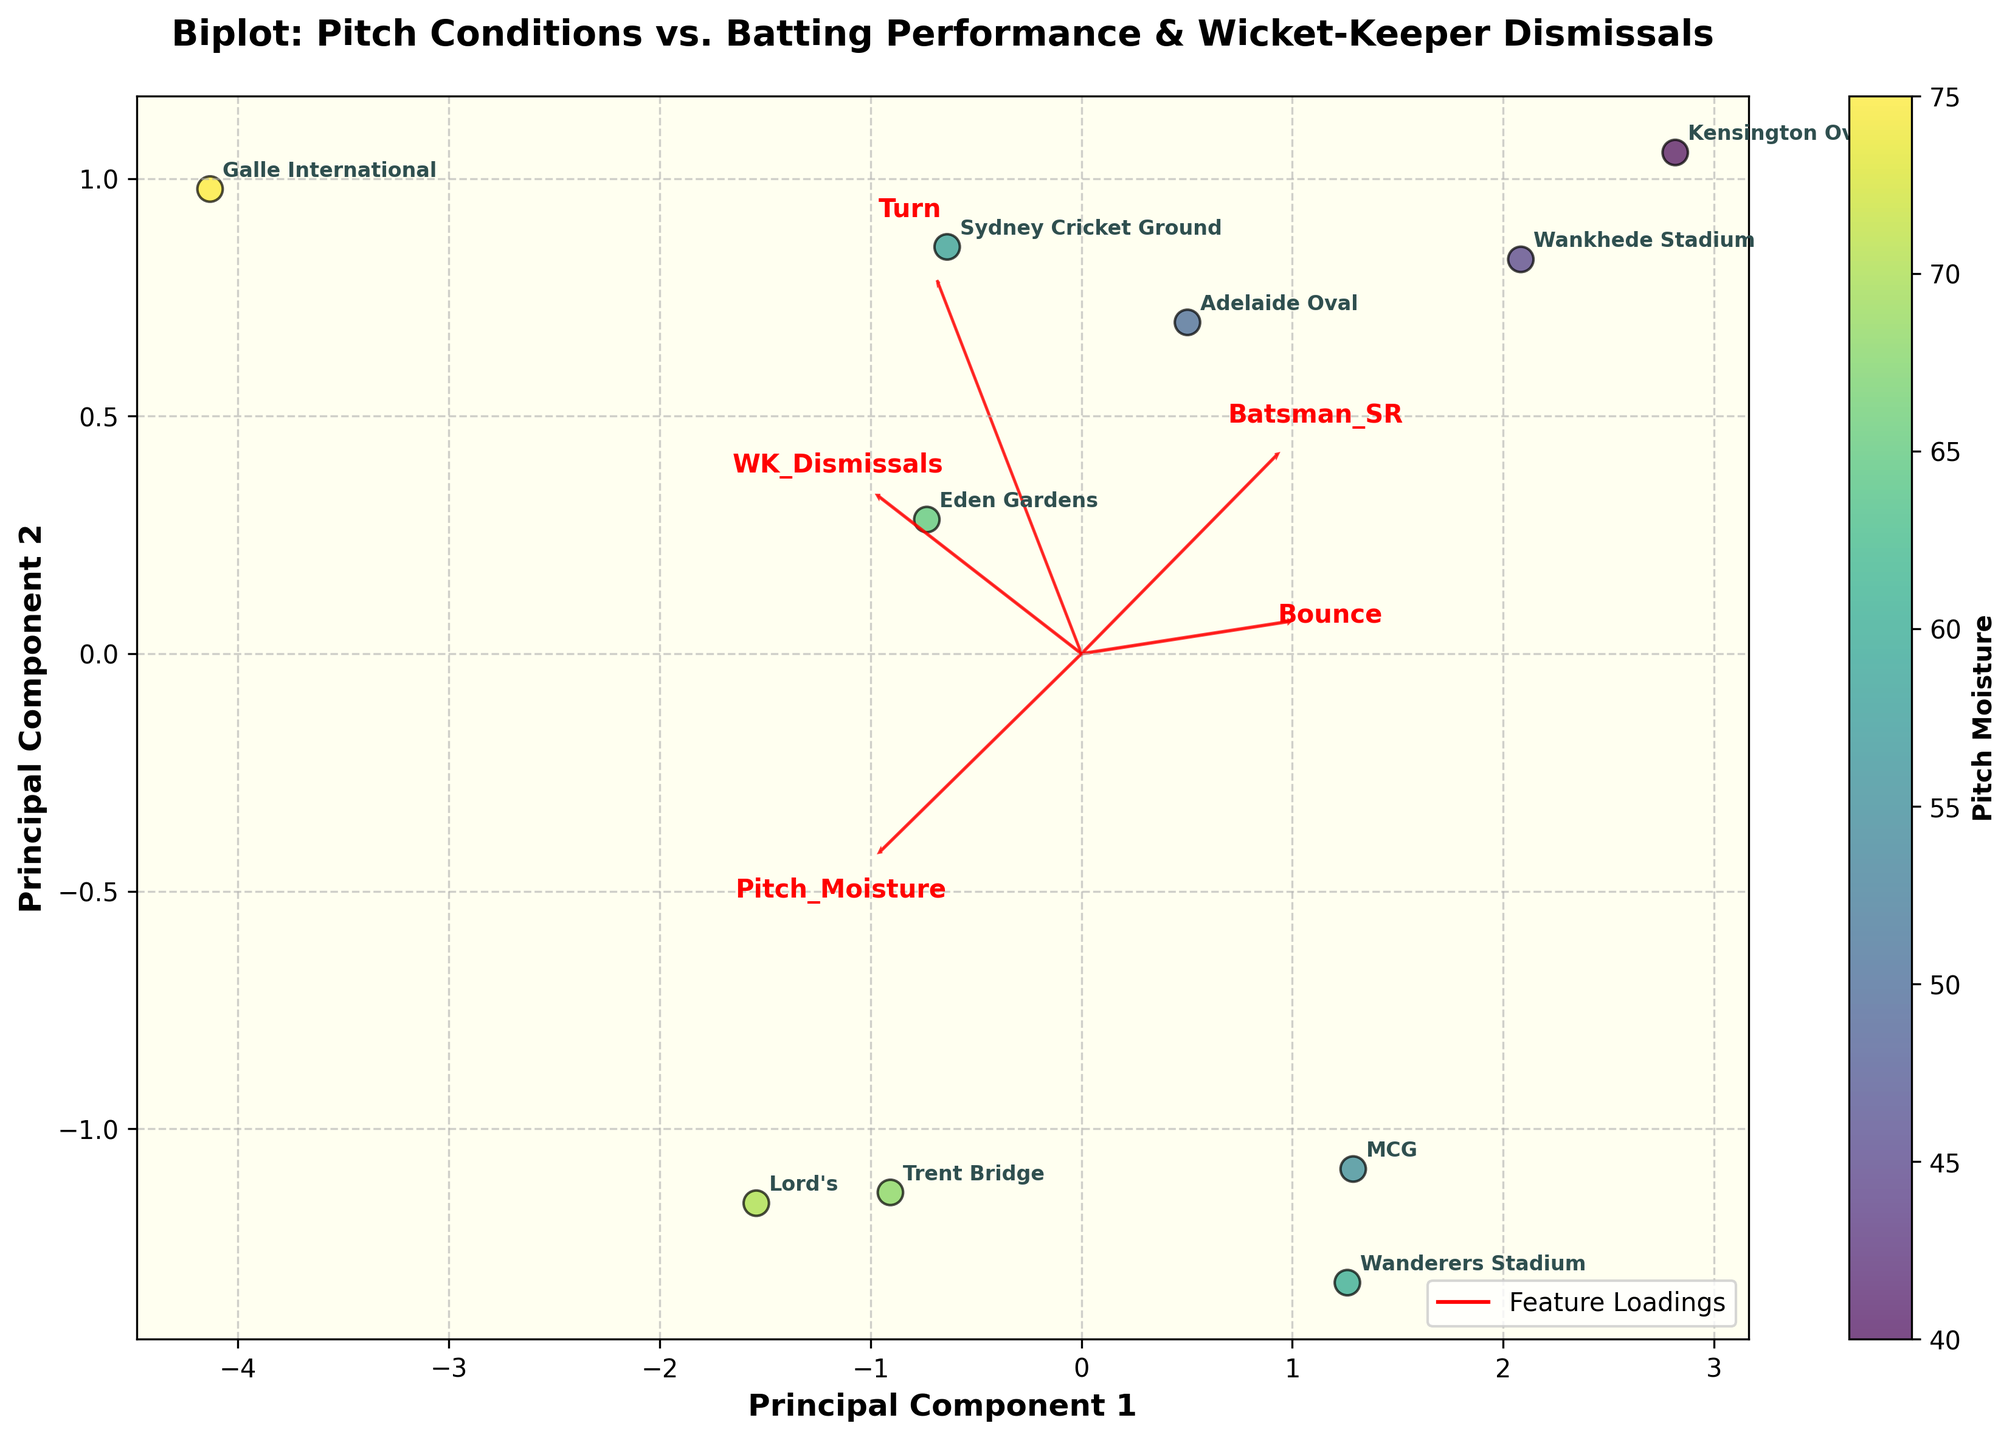What is the title of the biplot? The title of the biplot is displayed prominently at the top of the figure. By locating this text, you can identify the title of the biplot.
Answer: Biplot: Pitch Conditions vs. Batting Performance & Wicket-Keeper Dismissals How many stadiums are represented in the biplot? By counting the number of labeled points on the plot, each representing a stadium, you can determine the total number of stadiums plotted.
Answer: 10 Which stadium has the highest pitch moisture based on color intensity? The color intensity represents pitch moisture, with a darker color indicating higher moisture. By identifying the darkest point on the color bar, you can determine the stadium with the highest moisture.
Answer: Galle International What are the labels of the axes in the biplot? The axis labels can be identified directly from the plot, usually at the ends of the axis lines.
Answer: Principal Component 1 and Principal Component 2 Which feature has the highest loading on Principal Component 1? By looking at the direction and length of the red arrows on the plot, you can identify which feature has the highest contribution to Principal Component 1. The arrow which extends the farthest on the Principal Component 1 axis indicates the feature with the highest loading for that component.
Answer: Batsman_SR Which two stadiums are most similar in terms of their PC scores? By examining the positions of the data points on the plot, you can identify the two points that are closest to each other. These points represent the stadiums with the most similar Principal Component scores.
Answer: MCG and Wanderers Stadium How are 'Bounce' and 'Pitch Moisture' related? By observing the direction and alignment of the 'Bounce' and 'Pitch Moisture' arrows, you can infer their relationship. If the arrows point in similar directions, the features are positively correlated. If they point in opposite directions, they are negatively correlated.
Answer: Negatively correlated What does the color bar indicate? The color bar often indicates an additional dimension of data by showing a gradient of colors. In this case, by referring to the label provided next to the color bar, you can identify what it represents.
Answer: Pitch Moisture Which feature contributes least to Principal Component 2? The feature with the shortest arrow length along the Principal Component 2 axis contributes the least to that component. By comparing the lengths of all the arrows, you can find the feature with the shortest arrow.
Answer: Bounce Which stadium has the lowest batting strike rate? By looking at the plot and identifying which point (representing a stadium) is positioned closest to the arrow direction that points towards lower 'Batsman_SR' values, you can determine the stadium with the lowest batting strike rate.
Answer: Galle International 